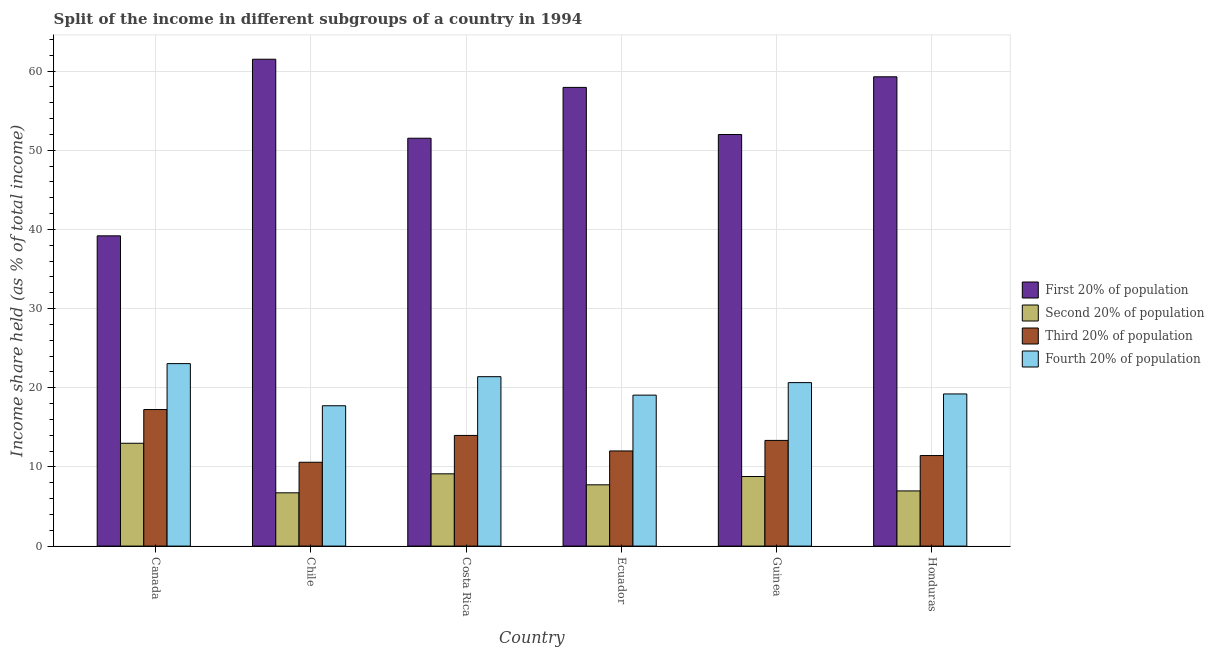Are the number of bars on each tick of the X-axis equal?
Provide a succinct answer. Yes. How many bars are there on the 6th tick from the right?
Keep it short and to the point. 4. What is the label of the 6th group of bars from the left?
Your answer should be compact. Honduras. What is the share of the income held by third 20% of the population in Honduras?
Give a very brief answer. 11.44. Across all countries, what is the maximum share of the income held by fourth 20% of the population?
Give a very brief answer. 23.05. Across all countries, what is the minimum share of the income held by first 20% of the population?
Give a very brief answer. 39.19. What is the total share of the income held by fourth 20% of the population in the graph?
Provide a succinct answer. 121.12. What is the difference between the share of the income held by third 20% of the population in Ecuador and that in Honduras?
Your response must be concise. 0.58. What is the difference between the share of the income held by fourth 20% of the population in Canada and the share of the income held by second 20% of the population in Chile?
Make the answer very short. 16.32. What is the average share of the income held by second 20% of the population per country?
Give a very brief answer. 8.72. What is the difference between the share of the income held by second 20% of the population and share of the income held by first 20% of the population in Canada?
Give a very brief answer. -26.2. What is the ratio of the share of the income held by third 20% of the population in Chile to that in Guinea?
Your response must be concise. 0.79. Is the share of the income held by fourth 20% of the population in Ecuador less than that in Honduras?
Offer a terse response. Yes. What is the difference between the highest and the second highest share of the income held by first 20% of the population?
Your answer should be compact. 2.22. What is the difference between the highest and the lowest share of the income held by third 20% of the population?
Give a very brief answer. 6.66. Is the sum of the share of the income held by third 20% of the population in Chile and Guinea greater than the maximum share of the income held by first 20% of the population across all countries?
Keep it short and to the point. No. What does the 3rd bar from the left in Costa Rica represents?
Make the answer very short. Third 20% of population. What does the 2nd bar from the right in Ecuador represents?
Your response must be concise. Third 20% of population. Is it the case that in every country, the sum of the share of the income held by first 20% of the population and share of the income held by second 20% of the population is greater than the share of the income held by third 20% of the population?
Give a very brief answer. Yes. Are all the bars in the graph horizontal?
Your answer should be very brief. No. How many countries are there in the graph?
Offer a very short reply. 6. Does the graph contain any zero values?
Give a very brief answer. No. Does the graph contain grids?
Your answer should be very brief. Yes. How many legend labels are there?
Ensure brevity in your answer.  4. How are the legend labels stacked?
Keep it short and to the point. Vertical. What is the title of the graph?
Provide a succinct answer. Split of the income in different subgroups of a country in 1994. What is the label or title of the X-axis?
Your response must be concise. Country. What is the label or title of the Y-axis?
Provide a succinct answer. Income share held (as % of total income). What is the Income share held (as % of total income) of First 20% of population in Canada?
Your response must be concise. 39.19. What is the Income share held (as % of total income) in Second 20% of population in Canada?
Your answer should be compact. 12.99. What is the Income share held (as % of total income) of Third 20% of population in Canada?
Your answer should be very brief. 17.25. What is the Income share held (as % of total income) in Fourth 20% of population in Canada?
Make the answer very short. 23.05. What is the Income share held (as % of total income) of First 20% of population in Chile?
Offer a terse response. 61.5. What is the Income share held (as % of total income) in Second 20% of population in Chile?
Provide a succinct answer. 6.73. What is the Income share held (as % of total income) in Third 20% of population in Chile?
Your response must be concise. 10.59. What is the Income share held (as % of total income) in Fourth 20% of population in Chile?
Your response must be concise. 17.73. What is the Income share held (as % of total income) in First 20% of population in Costa Rica?
Provide a short and direct response. 51.52. What is the Income share held (as % of total income) in Second 20% of population in Costa Rica?
Offer a very short reply. 9.13. What is the Income share held (as % of total income) of Third 20% of population in Costa Rica?
Provide a succinct answer. 13.98. What is the Income share held (as % of total income) of Fourth 20% of population in Costa Rica?
Offer a very short reply. 21.4. What is the Income share held (as % of total income) of First 20% of population in Ecuador?
Provide a short and direct response. 57.94. What is the Income share held (as % of total income) of Second 20% of population in Ecuador?
Your answer should be very brief. 7.74. What is the Income share held (as % of total income) of Third 20% of population in Ecuador?
Provide a succinct answer. 12.02. What is the Income share held (as % of total income) in Fourth 20% of population in Ecuador?
Give a very brief answer. 19.07. What is the Income share held (as % of total income) of First 20% of population in Guinea?
Your response must be concise. 51.99. What is the Income share held (as % of total income) in Second 20% of population in Guinea?
Make the answer very short. 8.79. What is the Income share held (as % of total income) in Third 20% of population in Guinea?
Ensure brevity in your answer.  13.35. What is the Income share held (as % of total income) of Fourth 20% of population in Guinea?
Your answer should be compact. 20.65. What is the Income share held (as % of total income) in First 20% of population in Honduras?
Keep it short and to the point. 59.28. What is the Income share held (as % of total income) of Second 20% of population in Honduras?
Give a very brief answer. 6.97. What is the Income share held (as % of total income) in Third 20% of population in Honduras?
Provide a short and direct response. 11.44. What is the Income share held (as % of total income) in Fourth 20% of population in Honduras?
Your response must be concise. 19.22. Across all countries, what is the maximum Income share held (as % of total income) of First 20% of population?
Your answer should be very brief. 61.5. Across all countries, what is the maximum Income share held (as % of total income) of Second 20% of population?
Offer a very short reply. 12.99. Across all countries, what is the maximum Income share held (as % of total income) of Third 20% of population?
Offer a very short reply. 17.25. Across all countries, what is the maximum Income share held (as % of total income) in Fourth 20% of population?
Your answer should be very brief. 23.05. Across all countries, what is the minimum Income share held (as % of total income) in First 20% of population?
Your answer should be compact. 39.19. Across all countries, what is the minimum Income share held (as % of total income) in Second 20% of population?
Ensure brevity in your answer.  6.73. Across all countries, what is the minimum Income share held (as % of total income) of Third 20% of population?
Provide a succinct answer. 10.59. Across all countries, what is the minimum Income share held (as % of total income) of Fourth 20% of population?
Provide a succinct answer. 17.73. What is the total Income share held (as % of total income) of First 20% of population in the graph?
Ensure brevity in your answer.  321.42. What is the total Income share held (as % of total income) of Second 20% of population in the graph?
Make the answer very short. 52.35. What is the total Income share held (as % of total income) of Third 20% of population in the graph?
Give a very brief answer. 78.63. What is the total Income share held (as % of total income) in Fourth 20% of population in the graph?
Offer a terse response. 121.12. What is the difference between the Income share held (as % of total income) of First 20% of population in Canada and that in Chile?
Provide a succinct answer. -22.31. What is the difference between the Income share held (as % of total income) in Second 20% of population in Canada and that in Chile?
Give a very brief answer. 6.26. What is the difference between the Income share held (as % of total income) of Third 20% of population in Canada and that in Chile?
Your response must be concise. 6.66. What is the difference between the Income share held (as % of total income) of Fourth 20% of population in Canada and that in Chile?
Make the answer very short. 5.32. What is the difference between the Income share held (as % of total income) in First 20% of population in Canada and that in Costa Rica?
Your answer should be very brief. -12.33. What is the difference between the Income share held (as % of total income) in Second 20% of population in Canada and that in Costa Rica?
Keep it short and to the point. 3.86. What is the difference between the Income share held (as % of total income) of Third 20% of population in Canada and that in Costa Rica?
Make the answer very short. 3.27. What is the difference between the Income share held (as % of total income) in Fourth 20% of population in Canada and that in Costa Rica?
Your answer should be compact. 1.65. What is the difference between the Income share held (as % of total income) in First 20% of population in Canada and that in Ecuador?
Your response must be concise. -18.75. What is the difference between the Income share held (as % of total income) in Second 20% of population in Canada and that in Ecuador?
Provide a succinct answer. 5.25. What is the difference between the Income share held (as % of total income) of Third 20% of population in Canada and that in Ecuador?
Offer a very short reply. 5.23. What is the difference between the Income share held (as % of total income) of Fourth 20% of population in Canada and that in Ecuador?
Provide a succinct answer. 3.98. What is the difference between the Income share held (as % of total income) of First 20% of population in Canada and that in Guinea?
Your answer should be very brief. -12.8. What is the difference between the Income share held (as % of total income) of Second 20% of population in Canada and that in Guinea?
Your response must be concise. 4.2. What is the difference between the Income share held (as % of total income) in Third 20% of population in Canada and that in Guinea?
Offer a terse response. 3.9. What is the difference between the Income share held (as % of total income) in Fourth 20% of population in Canada and that in Guinea?
Ensure brevity in your answer.  2.4. What is the difference between the Income share held (as % of total income) of First 20% of population in Canada and that in Honduras?
Your answer should be compact. -20.09. What is the difference between the Income share held (as % of total income) in Second 20% of population in Canada and that in Honduras?
Your response must be concise. 6.02. What is the difference between the Income share held (as % of total income) in Third 20% of population in Canada and that in Honduras?
Provide a succinct answer. 5.81. What is the difference between the Income share held (as % of total income) in Fourth 20% of population in Canada and that in Honduras?
Make the answer very short. 3.83. What is the difference between the Income share held (as % of total income) in First 20% of population in Chile and that in Costa Rica?
Provide a succinct answer. 9.98. What is the difference between the Income share held (as % of total income) in Second 20% of population in Chile and that in Costa Rica?
Offer a terse response. -2.4. What is the difference between the Income share held (as % of total income) in Third 20% of population in Chile and that in Costa Rica?
Keep it short and to the point. -3.39. What is the difference between the Income share held (as % of total income) of Fourth 20% of population in Chile and that in Costa Rica?
Ensure brevity in your answer.  -3.67. What is the difference between the Income share held (as % of total income) of First 20% of population in Chile and that in Ecuador?
Make the answer very short. 3.56. What is the difference between the Income share held (as % of total income) of Second 20% of population in Chile and that in Ecuador?
Offer a terse response. -1.01. What is the difference between the Income share held (as % of total income) of Third 20% of population in Chile and that in Ecuador?
Your response must be concise. -1.43. What is the difference between the Income share held (as % of total income) of Fourth 20% of population in Chile and that in Ecuador?
Give a very brief answer. -1.34. What is the difference between the Income share held (as % of total income) of First 20% of population in Chile and that in Guinea?
Your answer should be very brief. 9.51. What is the difference between the Income share held (as % of total income) of Second 20% of population in Chile and that in Guinea?
Offer a terse response. -2.06. What is the difference between the Income share held (as % of total income) in Third 20% of population in Chile and that in Guinea?
Offer a terse response. -2.76. What is the difference between the Income share held (as % of total income) in Fourth 20% of population in Chile and that in Guinea?
Your answer should be compact. -2.92. What is the difference between the Income share held (as % of total income) in First 20% of population in Chile and that in Honduras?
Ensure brevity in your answer.  2.22. What is the difference between the Income share held (as % of total income) in Second 20% of population in Chile and that in Honduras?
Make the answer very short. -0.24. What is the difference between the Income share held (as % of total income) of Third 20% of population in Chile and that in Honduras?
Provide a succinct answer. -0.85. What is the difference between the Income share held (as % of total income) in Fourth 20% of population in Chile and that in Honduras?
Make the answer very short. -1.49. What is the difference between the Income share held (as % of total income) of First 20% of population in Costa Rica and that in Ecuador?
Your answer should be compact. -6.42. What is the difference between the Income share held (as % of total income) of Second 20% of population in Costa Rica and that in Ecuador?
Keep it short and to the point. 1.39. What is the difference between the Income share held (as % of total income) in Third 20% of population in Costa Rica and that in Ecuador?
Your answer should be compact. 1.96. What is the difference between the Income share held (as % of total income) of Fourth 20% of population in Costa Rica and that in Ecuador?
Offer a terse response. 2.33. What is the difference between the Income share held (as % of total income) of First 20% of population in Costa Rica and that in Guinea?
Give a very brief answer. -0.47. What is the difference between the Income share held (as % of total income) in Second 20% of population in Costa Rica and that in Guinea?
Give a very brief answer. 0.34. What is the difference between the Income share held (as % of total income) of Third 20% of population in Costa Rica and that in Guinea?
Keep it short and to the point. 0.63. What is the difference between the Income share held (as % of total income) of First 20% of population in Costa Rica and that in Honduras?
Provide a succinct answer. -7.76. What is the difference between the Income share held (as % of total income) of Second 20% of population in Costa Rica and that in Honduras?
Your answer should be very brief. 2.16. What is the difference between the Income share held (as % of total income) of Third 20% of population in Costa Rica and that in Honduras?
Offer a terse response. 2.54. What is the difference between the Income share held (as % of total income) of Fourth 20% of population in Costa Rica and that in Honduras?
Your answer should be compact. 2.18. What is the difference between the Income share held (as % of total income) in First 20% of population in Ecuador and that in Guinea?
Ensure brevity in your answer.  5.95. What is the difference between the Income share held (as % of total income) in Second 20% of population in Ecuador and that in Guinea?
Your response must be concise. -1.05. What is the difference between the Income share held (as % of total income) of Third 20% of population in Ecuador and that in Guinea?
Offer a terse response. -1.33. What is the difference between the Income share held (as % of total income) of Fourth 20% of population in Ecuador and that in Guinea?
Ensure brevity in your answer.  -1.58. What is the difference between the Income share held (as % of total income) in First 20% of population in Ecuador and that in Honduras?
Offer a terse response. -1.34. What is the difference between the Income share held (as % of total income) of Second 20% of population in Ecuador and that in Honduras?
Offer a terse response. 0.77. What is the difference between the Income share held (as % of total income) of Third 20% of population in Ecuador and that in Honduras?
Give a very brief answer. 0.58. What is the difference between the Income share held (as % of total income) in First 20% of population in Guinea and that in Honduras?
Your answer should be compact. -7.29. What is the difference between the Income share held (as % of total income) of Second 20% of population in Guinea and that in Honduras?
Give a very brief answer. 1.82. What is the difference between the Income share held (as % of total income) in Third 20% of population in Guinea and that in Honduras?
Provide a short and direct response. 1.91. What is the difference between the Income share held (as % of total income) in Fourth 20% of population in Guinea and that in Honduras?
Your answer should be very brief. 1.43. What is the difference between the Income share held (as % of total income) in First 20% of population in Canada and the Income share held (as % of total income) in Second 20% of population in Chile?
Your response must be concise. 32.46. What is the difference between the Income share held (as % of total income) of First 20% of population in Canada and the Income share held (as % of total income) of Third 20% of population in Chile?
Make the answer very short. 28.6. What is the difference between the Income share held (as % of total income) of First 20% of population in Canada and the Income share held (as % of total income) of Fourth 20% of population in Chile?
Keep it short and to the point. 21.46. What is the difference between the Income share held (as % of total income) in Second 20% of population in Canada and the Income share held (as % of total income) in Fourth 20% of population in Chile?
Make the answer very short. -4.74. What is the difference between the Income share held (as % of total income) of Third 20% of population in Canada and the Income share held (as % of total income) of Fourth 20% of population in Chile?
Your answer should be very brief. -0.48. What is the difference between the Income share held (as % of total income) of First 20% of population in Canada and the Income share held (as % of total income) of Second 20% of population in Costa Rica?
Provide a succinct answer. 30.06. What is the difference between the Income share held (as % of total income) of First 20% of population in Canada and the Income share held (as % of total income) of Third 20% of population in Costa Rica?
Your answer should be compact. 25.21. What is the difference between the Income share held (as % of total income) of First 20% of population in Canada and the Income share held (as % of total income) of Fourth 20% of population in Costa Rica?
Your answer should be compact. 17.79. What is the difference between the Income share held (as % of total income) of Second 20% of population in Canada and the Income share held (as % of total income) of Third 20% of population in Costa Rica?
Your answer should be very brief. -0.99. What is the difference between the Income share held (as % of total income) in Second 20% of population in Canada and the Income share held (as % of total income) in Fourth 20% of population in Costa Rica?
Provide a short and direct response. -8.41. What is the difference between the Income share held (as % of total income) of Third 20% of population in Canada and the Income share held (as % of total income) of Fourth 20% of population in Costa Rica?
Provide a succinct answer. -4.15. What is the difference between the Income share held (as % of total income) of First 20% of population in Canada and the Income share held (as % of total income) of Second 20% of population in Ecuador?
Your answer should be very brief. 31.45. What is the difference between the Income share held (as % of total income) of First 20% of population in Canada and the Income share held (as % of total income) of Third 20% of population in Ecuador?
Your answer should be compact. 27.17. What is the difference between the Income share held (as % of total income) in First 20% of population in Canada and the Income share held (as % of total income) in Fourth 20% of population in Ecuador?
Your answer should be very brief. 20.12. What is the difference between the Income share held (as % of total income) of Second 20% of population in Canada and the Income share held (as % of total income) of Fourth 20% of population in Ecuador?
Your answer should be compact. -6.08. What is the difference between the Income share held (as % of total income) of Third 20% of population in Canada and the Income share held (as % of total income) of Fourth 20% of population in Ecuador?
Offer a terse response. -1.82. What is the difference between the Income share held (as % of total income) in First 20% of population in Canada and the Income share held (as % of total income) in Second 20% of population in Guinea?
Offer a very short reply. 30.4. What is the difference between the Income share held (as % of total income) of First 20% of population in Canada and the Income share held (as % of total income) of Third 20% of population in Guinea?
Provide a short and direct response. 25.84. What is the difference between the Income share held (as % of total income) of First 20% of population in Canada and the Income share held (as % of total income) of Fourth 20% of population in Guinea?
Keep it short and to the point. 18.54. What is the difference between the Income share held (as % of total income) in Second 20% of population in Canada and the Income share held (as % of total income) in Third 20% of population in Guinea?
Provide a short and direct response. -0.36. What is the difference between the Income share held (as % of total income) in Second 20% of population in Canada and the Income share held (as % of total income) in Fourth 20% of population in Guinea?
Ensure brevity in your answer.  -7.66. What is the difference between the Income share held (as % of total income) of Third 20% of population in Canada and the Income share held (as % of total income) of Fourth 20% of population in Guinea?
Your answer should be compact. -3.4. What is the difference between the Income share held (as % of total income) in First 20% of population in Canada and the Income share held (as % of total income) in Second 20% of population in Honduras?
Give a very brief answer. 32.22. What is the difference between the Income share held (as % of total income) of First 20% of population in Canada and the Income share held (as % of total income) of Third 20% of population in Honduras?
Make the answer very short. 27.75. What is the difference between the Income share held (as % of total income) in First 20% of population in Canada and the Income share held (as % of total income) in Fourth 20% of population in Honduras?
Offer a very short reply. 19.97. What is the difference between the Income share held (as % of total income) in Second 20% of population in Canada and the Income share held (as % of total income) in Third 20% of population in Honduras?
Make the answer very short. 1.55. What is the difference between the Income share held (as % of total income) in Second 20% of population in Canada and the Income share held (as % of total income) in Fourth 20% of population in Honduras?
Your answer should be compact. -6.23. What is the difference between the Income share held (as % of total income) in Third 20% of population in Canada and the Income share held (as % of total income) in Fourth 20% of population in Honduras?
Provide a succinct answer. -1.97. What is the difference between the Income share held (as % of total income) of First 20% of population in Chile and the Income share held (as % of total income) of Second 20% of population in Costa Rica?
Ensure brevity in your answer.  52.37. What is the difference between the Income share held (as % of total income) in First 20% of population in Chile and the Income share held (as % of total income) in Third 20% of population in Costa Rica?
Offer a very short reply. 47.52. What is the difference between the Income share held (as % of total income) in First 20% of population in Chile and the Income share held (as % of total income) in Fourth 20% of population in Costa Rica?
Ensure brevity in your answer.  40.1. What is the difference between the Income share held (as % of total income) in Second 20% of population in Chile and the Income share held (as % of total income) in Third 20% of population in Costa Rica?
Make the answer very short. -7.25. What is the difference between the Income share held (as % of total income) in Second 20% of population in Chile and the Income share held (as % of total income) in Fourth 20% of population in Costa Rica?
Provide a short and direct response. -14.67. What is the difference between the Income share held (as % of total income) in Third 20% of population in Chile and the Income share held (as % of total income) in Fourth 20% of population in Costa Rica?
Your answer should be compact. -10.81. What is the difference between the Income share held (as % of total income) of First 20% of population in Chile and the Income share held (as % of total income) of Second 20% of population in Ecuador?
Provide a succinct answer. 53.76. What is the difference between the Income share held (as % of total income) of First 20% of population in Chile and the Income share held (as % of total income) of Third 20% of population in Ecuador?
Your answer should be very brief. 49.48. What is the difference between the Income share held (as % of total income) in First 20% of population in Chile and the Income share held (as % of total income) in Fourth 20% of population in Ecuador?
Make the answer very short. 42.43. What is the difference between the Income share held (as % of total income) in Second 20% of population in Chile and the Income share held (as % of total income) in Third 20% of population in Ecuador?
Your answer should be compact. -5.29. What is the difference between the Income share held (as % of total income) of Second 20% of population in Chile and the Income share held (as % of total income) of Fourth 20% of population in Ecuador?
Offer a terse response. -12.34. What is the difference between the Income share held (as % of total income) in Third 20% of population in Chile and the Income share held (as % of total income) in Fourth 20% of population in Ecuador?
Offer a terse response. -8.48. What is the difference between the Income share held (as % of total income) of First 20% of population in Chile and the Income share held (as % of total income) of Second 20% of population in Guinea?
Your answer should be compact. 52.71. What is the difference between the Income share held (as % of total income) in First 20% of population in Chile and the Income share held (as % of total income) in Third 20% of population in Guinea?
Offer a very short reply. 48.15. What is the difference between the Income share held (as % of total income) of First 20% of population in Chile and the Income share held (as % of total income) of Fourth 20% of population in Guinea?
Provide a short and direct response. 40.85. What is the difference between the Income share held (as % of total income) of Second 20% of population in Chile and the Income share held (as % of total income) of Third 20% of population in Guinea?
Your answer should be very brief. -6.62. What is the difference between the Income share held (as % of total income) of Second 20% of population in Chile and the Income share held (as % of total income) of Fourth 20% of population in Guinea?
Offer a very short reply. -13.92. What is the difference between the Income share held (as % of total income) of Third 20% of population in Chile and the Income share held (as % of total income) of Fourth 20% of population in Guinea?
Give a very brief answer. -10.06. What is the difference between the Income share held (as % of total income) in First 20% of population in Chile and the Income share held (as % of total income) in Second 20% of population in Honduras?
Give a very brief answer. 54.53. What is the difference between the Income share held (as % of total income) of First 20% of population in Chile and the Income share held (as % of total income) of Third 20% of population in Honduras?
Give a very brief answer. 50.06. What is the difference between the Income share held (as % of total income) in First 20% of population in Chile and the Income share held (as % of total income) in Fourth 20% of population in Honduras?
Offer a very short reply. 42.28. What is the difference between the Income share held (as % of total income) in Second 20% of population in Chile and the Income share held (as % of total income) in Third 20% of population in Honduras?
Keep it short and to the point. -4.71. What is the difference between the Income share held (as % of total income) in Second 20% of population in Chile and the Income share held (as % of total income) in Fourth 20% of population in Honduras?
Your answer should be very brief. -12.49. What is the difference between the Income share held (as % of total income) of Third 20% of population in Chile and the Income share held (as % of total income) of Fourth 20% of population in Honduras?
Give a very brief answer. -8.63. What is the difference between the Income share held (as % of total income) of First 20% of population in Costa Rica and the Income share held (as % of total income) of Second 20% of population in Ecuador?
Offer a very short reply. 43.78. What is the difference between the Income share held (as % of total income) in First 20% of population in Costa Rica and the Income share held (as % of total income) in Third 20% of population in Ecuador?
Your response must be concise. 39.5. What is the difference between the Income share held (as % of total income) in First 20% of population in Costa Rica and the Income share held (as % of total income) in Fourth 20% of population in Ecuador?
Your answer should be very brief. 32.45. What is the difference between the Income share held (as % of total income) in Second 20% of population in Costa Rica and the Income share held (as % of total income) in Third 20% of population in Ecuador?
Your answer should be compact. -2.89. What is the difference between the Income share held (as % of total income) in Second 20% of population in Costa Rica and the Income share held (as % of total income) in Fourth 20% of population in Ecuador?
Your answer should be compact. -9.94. What is the difference between the Income share held (as % of total income) in Third 20% of population in Costa Rica and the Income share held (as % of total income) in Fourth 20% of population in Ecuador?
Your answer should be very brief. -5.09. What is the difference between the Income share held (as % of total income) of First 20% of population in Costa Rica and the Income share held (as % of total income) of Second 20% of population in Guinea?
Provide a succinct answer. 42.73. What is the difference between the Income share held (as % of total income) of First 20% of population in Costa Rica and the Income share held (as % of total income) of Third 20% of population in Guinea?
Your answer should be very brief. 38.17. What is the difference between the Income share held (as % of total income) of First 20% of population in Costa Rica and the Income share held (as % of total income) of Fourth 20% of population in Guinea?
Offer a very short reply. 30.87. What is the difference between the Income share held (as % of total income) of Second 20% of population in Costa Rica and the Income share held (as % of total income) of Third 20% of population in Guinea?
Provide a short and direct response. -4.22. What is the difference between the Income share held (as % of total income) of Second 20% of population in Costa Rica and the Income share held (as % of total income) of Fourth 20% of population in Guinea?
Your response must be concise. -11.52. What is the difference between the Income share held (as % of total income) of Third 20% of population in Costa Rica and the Income share held (as % of total income) of Fourth 20% of population in Guinea?
Your answer should be very brief. -6.67. What is the difference between the Income share held (as % of total income) of First 20% of population in Costa Rica and the Income share held (as % of total income) of Second 20% of population in Honduras?
Provide a short and direct response. 44.55. What is the difference between the Income share held (as % of total income) in First 20% of population in Costa Rica and the Income share held (as % of total income) in Third 20% of population in Honduras?
Your answer should be compact. 40.08. What is the difference between the Income share held (as % of total income) of First 20% of population in Costa Rica and the Income share held (as % of total income) of Fourth 20% of population in Honduras?
Offer a very short reply. 32.3. What is the difference between the Income share held (as % of total income) of Second 20% of population in Costa Rica and the Income share held (as % of total income) of Third 20% of population in Honduras?
Keep it short and to the point. -2.31. What is the difference between the Income share held (as % of total income) in Second 20% of population in Costa Rica and the Income share held (as % of total income) in Fourth 20% of population in Honduras?
Give a very brief answer. -10.09. What is the difference between the Income share held (as % of total income) of Third 20% of population in Costa Rica and the Income share held (as % of total income) of Fourth 20% of population in Honduras?
Provide a short and direct response. -5.24. What is the difference between the Income share held (as % of total income) in First 20% of population in Ecuador and the Income share held (as % of total income) in Second 20% of population in Guinea?
Ensure brevity in your answer.  49.15. What is the difference between the Income share held (as % of total income) in First 20% of population in Ecuador and the Income share held (as % of total income) in Third 20% of population in Guinea?
Ensure brevity in your answer.  44.59. What is the difference between the Income share held (as % of total income) of First 20% of population in Ecuador and the Income share held (as % of total income) of Fourth 20% of population in Guinea?
Provide a succinct answer. 37.29. What is the difference between the Income share held (as % of total income) in Second 20% of population in Ecuador and the Income share held (as % of total income) in Third 20% of population in Guinea?
Give a very brief answer. -5.61. What is the difference between the Income share held (as % of total income) in Second 20% of population in Ecuador and the Income share held (as % of total income) in Fourth 20% of population in Guinea?
Give a very brief answer. -12.91. What is the difference between the Income share held (as % of total income) of Third 20% of population in Ecuador and the Income share held (as % of total income) of Fourth 20% of population in Guinea?
Ensure brevity in your answer.  -8.63. What is the difference between the Income share held (as % of total income) of First 20% of population in Ecuador and the Income share held (as % of total income) of Second 20% of population in Honduras?
Provide a succinct answer. 50.97. What is the difference between the Income share held (as % of total income) in First 20% of population in Ecuador and the Income share held (as % of total income) in Third 20% of population in Honduras?
Offer a very short reply. 46.5. What is the difference between the Income share held (as % of total income) in First 20% of population in Ecuador and the Income share held (as % of total income) in Fourth 20% of population in Honduras?
Give a very brief answer. 38.72. What is the difference between the Income share held (as % of total income) in Second 20% of population in Ecuador and the Income share held (as % of total income) in Fourth 20% of population in Honduras?
Give a very brief answer. -11.48. What is the difference between the Income share held (as % of total income) in First 20% of population in Guinea and the Income share held (as % of total income) in Second 20% of population in Honduras?
Keep it short and to the point. 45.02. What is the difference between the Income share held (as % of total income) in First 20% of population in Guinea and the Income share held (as % of total income) in Third 20% of population in Honduras?
Offer a terse response. 40.55. What is the difference between the Income share held (as % of total income) of First 20% of population in Guinea and the Income share held (as % of total income) of Fourth 20% of population in Honduras?
Your answer should be compact. 32.77. What is the difference between the Income share held (as % of total income) in Second 20% of population in Guinea and the Income share held (as % of total income) in Third 20% of population in Honduras?
Provide a succinct answer. -2.65. What is the difference between the Income share held (as % of total income) of Second 20% of population in Guinea and the Income share held (as % of total income) of Fourth 20% of population in Honduras?
Provide a succinct answer. -10.43. What is the difference between the Income share held (as % of total income) of Third 20% of population in Guinea and the Income share held (as % of total income) of Fourth 20% of population in Honduras?
Offer a very short reply. -5.87. What is the average Income share held (as % of total income) in First 20% of population per country?
Provide a succinct answer. 53.57. What is the average Income share held (as % of total income) of Second 20% of population per country?
Keep it short and to the point. 8.72. What is the average Income share held (as % of total income) in Third 20% of population per country?
Your answer should be very brief. 13.11. What is the average Income share held (as % of total income) in Fourth 20% of population per country?
Keep it short and to the point. 20.19. What is the difference between the Income share held (as % of total income) of First 20% of population and Income share held (as % of total income) of Second 20% of population in Canada?
Your answer should be very brief. 26.2. What is the difference between the Income share held (as % of total income) in First 20% of population and Income share held (as % of total income) in Third 20% of population in Canada?
Give a very brief answer. 21.94. What is the difference between the Income share held (as % of total income) of First 20% of population and Income share held (as % of total income) of Fourth 20% of population in Canada?
Make the answer very short. 16.14. What is the difference between the Income share held (as % of total income) of Second 20% of population and Income share held (as % of total income) of Third 20% of population in Canada?
Your answer should be very brief. -4.26. What is the difference between the Income share held (as % of total income) in Second 20% of population and Income share held (as % of total income) in Fourth 20% of population in Canada?
Provide a short and direct response. -10.06. What is the difference between the Income share held (as % of total income) of Third 20% of population and Income share held (as % of total income) of Fourth 20% of population in Canada?
Your answer should be very brief. -5.8. What is the difference between the Income share held (as % of total income) of First 20% of population and Income share held (as % of total income) of Second 20% of population in Chile?
Give a very brief answer. 54.77. What is the difference between the Income share held (as % of total income) in First 20% of population and Income share held (as % of total income) in Third 20% of population in Chile?
Your answer should be very brief. 50.91. What is the difference between the Income share held (as % of total income) in First 20% of population and Income share held (as % of total income) in Fourth 20% of population in Chile?
Provide a succinct answer. 43.77. What is the difference between the Income share held (as % of total income) in Second 20% of population and Income share held (as % of total income) in Third 20% of population in Chile?
Your response must be concise. -3.86. What is the difference between the Income share held (as % of total income) in Second 20% of population and Income share held (as % of total income) in Fourth 20% of population in Chile?
Provide a short and direct response. -11. What is the difference between the Income share held (as % of total income) of Third 20% of population and Income share held (as % of total income) of Fourth 20% of population in Chile?
Provide a succinct answer. -7.14. What is the difference between the Income share held (as % of total income) in First 20% of population and Income share held (as % of total income) in Second 20% of population in Costa Rica?
Provide a succinct answer. 42.39. What is the difference between the Income share held (as % of total income) of First 20% of population and Income share held (as % of total income) of Third 20% of population in Costa Rica?
Your response must be concise. 37.54. What is the difference between the Income share held (as % of total income) of First 20% of population and Income share held (as % of total income) of Fourth 20% of population in Costa Rica?
Offer a very short reply. 30.12. What is the difference between the Income share held (as % of total income) in Second 20% of population and Income share held (as % of total income) in Third 20% of population in Costa Rica?
Your answer should be compact. -4.85. What is the difference between the Income share held (as % of total income) of Second 20% of population and Income share held (as % of total income) of Fourth 20% of population in Costa Rica?
Keep it short and to the point. -12.27. What is the difference between the Income share held (as % of total income) of Third 20% of population and Income share held (as % of total income) of Fourth 20% of population in Costa Rica?
Make the answer very short. -7.42. What is the difference between the Income share held (as % of total income) in First 20% of population and Income share held (as % of total income) in Second 20% of population in Ecuador?
Your response must be concise. 50.2. What is the difference between the Income share held (as % of total income) of First 20% of population and Income share held (as % of total income) of Third 20% of population in Ecuador?
Your answer should be compact. 45.92. What is the difference between the Income share held (as % of total income) of First 20% of population and Income share held (as % of total income) of Fourth 20% of population in Ecuador?
Keep it short and to the point. 38.87. What is the difference between the Income share held (as % of total income) in Second 20% of population and Income share held (as % of total income) in Third 20% of population in Ecuador?
Provide a succinct answer. -4.28. What is the difference between the Income share held (as % of total income) of Second 20% of population and Income share held (as % of total income) of Fourth 20% of population in Ecuador?
Make the answer very short. -11.33. What is the difference between the Income share held (as % of total income) of Third 20% of population and Income share held (as % of total income) of Fourth 20% of population in Ecuador?
Your response must be concise. -7.05. What is the difference between the Income share held (as % of total income) of First 20% of population and Income share held (as % of total income) of Second 20% of population in Guinea?
Your response must be concise. 43.2. What is the difference between the Income share held (as % of total income) of First 20% of population and Income share held (as % of total income) of Third 20% of population in Guinea?
Provide a short and direct response. 38.64. What is the difference between the Income share held (as % of total income) in First 20% of population and Income share held (as % of total income) in Fourth 20% of population in Guinea?
Offer a very short reply. 31.34. What is the difference between the Income share held (as % of total income) in Second 20% of population and Income share held (as % of total income) in Third 20% of population in Guinea?
Your answer should be compact. -4.56. What is the difference between the Income share held (as % of total income) of Second 20% of population and Income share held (as % of total income) of Fourth 20% of population in Guinea?
Your answer should be compact. -11.86. What is the difference between the Income share held (as % of total income) in Third 20% of population and Income share held (as % of total income) in Fourth 20% of population in Guinea?
Your response must be concise. -7.3. What is the difference between the Income share held (as % of total income) in First 20% of population and Income share held (as % of total income) in Second 20% of population in Honduras?
Give a very brief answer. 52.31. What is the difference between the Income share held (as % of total income) in First 20% of population and Income share held (as % of total income) in Third 20% of population in Honduras?
Make the answer very short. 47.84. What is the difference between the Income share held (as % of total income) of First 20% of population and Income share held (as % of total income) of Fourth 20% of population in Honduras?
Your answer should be compact. 40.06. What is the difference between the Income share held (as % of total income) of Second 20% of population and Income share held (as % of total income) of Third 20% of population in Honduras?
Offer a very short reply. -4.47. What is the difference between the Income share held (as % of total income) of Second 20% of population and Income share held (as % of total income) of Fourth 20% of population in Honduras?
Ensure brevity in your answer.  -12.25. What is the difference between the Income share held (as % of total income) in Third 20% of population and Income share held (as % of total income) in Fourth 20% of population in Honduras?
Provide a short and direct response. -7.78. What is the ratio of the Income share held (as % of total income) in First 20% of population in Canada to that in Chile?
Provide a short and direct response. 0.64. What is the ratio of the Income share held (as % of total income) of Second 20% of population in Canada to that in Chile?
Your answer should be compact. 1.93. What is the ratio of the Income share held (as % of total income) in Third 20% of population in Canada to that in Chile?
Provide a succinct answer. 1.63. What is the ratio of the Income share held (as % of total income) in Fourth 20% of population in Canada to that in Chile?
Keep it short and to the point. 1.3. What is the ratio of the Income share held (as % of total income) in First 20% of population in Canada to that in Costa Rica?
Your answer should be compact. 0.76. What is the ratio of the Income share held (as % of total income) of Second 20% of population in Canada to that in Costa Rica?
Ensure brevity in your answer.  1.42. What is the ratio of the Income share held (as % of total income) of Third 20% of population in Canada to that in Costa Rica?
Your response must be concise. 1.23. What is the ratio of the Income share held (as % of total income) in Fourth 20% of population in Canada to that in Costa Rica?
Give a very brief answer. 1.08. What is the ratio of the Income share held (as % of total income) of First 20% of population in Canada to that in Ecuador?
Make the answer very short. 0.68. What is the ratio of the Income share held (as % of total income) of Second 20% of population in Canada to that in Ecuador?
Provide a succinct answer. 1.68. What is the ratio of the Income share held (as % of total income) in Third 20% of population in Canada to that in Ecuador?
Keep it short and to the point. 1.44. What is the ratio of the Income share held (as % of total income) of Fourth 20% of population in Canada to that in Ecuador?
Give a very brief answer. 1.21. What is the ratio of the Income share held (as % of total income) of First 20% of population in Canada to that in Guinea?
Make the answer very short. 0.75. What is the ratio of the Income share held (as % of total income) of Second 20% of population in Canada to that in Guinea?
Provide a short and direct response. 1.48. What is the ratio of the Income share held (as % of total income) in Third 20% of population in Canada to that in Guinea?
Your response must be concise. 1.29. What is the ratio of the Income share held (as % of total income) in Fourth 20% of population in Canada to that in Guinea?
Give a very brief answer. 1.12. What is the ratio of the Income share held (as % of total income) of First 20% of population in Canada to that in Honduras?
Provide a short and direct response. 0.66. What is the ratio of the Income share held (as % of total income) in Second 20% of population in Canada to that in Honduras?
Keep it short and to the point. 1.86. What is the ratio of the Income share held (as % of total income) of Third 20% of population in Canada to that in Honduras?
Offer a very short reply. 1.51. What is the ratio of the Income share held (as % of total income) of Fourth 20% of population in Canada to that in Honduras?
Offer a very short reply. 1.2. What is the ratio of the Income share held (as % of total income) of First 20% of population in Chile to that in Costa Rica?
Give a very brief answer. 1.19. What is the ratio of the Income share held (as % of total income) in Second 20% of population in Chile to that in Costa Rica?
Your answer should be very brief. 0.74. What is the ratio of the Income share held (as % of total income) in Third 20% of population in Chile to that in Costa Rica?
Offer a very short reply. 0.76. What is the ratio of the Income share held (as % of total income) of Fourth 20% of population in Chile to that in Costa Rica?
Make the answer very short. 0.83. What is the ratio of the Income share held (as % of total income) in First 20% of population in Chile to that in Ecuador?
Provide a succinct answer. 1.06. What is the ratio of the Income share held (as % of total income) in Second 20% of population in Chile to that in Ecuador?
Offer a very short reply. 0.87. What is the ratio of the Income share held (as % of total income) of Third 20% of population in Chile to that in Ecuador?
Your answer should be compact. 0.88. What is the ratio of the Income share held (as % of total income) of Fourth 20% of population in Chile to that in Ecuador?
Offer a terse response. 0.93. What is the ratio of the Income share held (as % of total income) in First 20% of population in Chile to that in Guinea?
Keep it short and to the point. 1.18. What is the ratio of the Income share held (as % of total income) in Second 20% of population in Chile to that in Guinea?
Your response must be concise. 0.77. What is the ratio of the Income share held (as % of total income) of Third 20% of population in Chile to that in Guinea?
Your answer should be compact. 0.79. What is the ratio of the Income share held (as % of total income) of Fourth 20% of population in Chile to that in Guinea?
Offer a very short reply. 0.86. What is the ratio of the Income share held (as % of total income) in First 20% of population in Chile to that in Honduras?
Offer a terse response. 1.04. What is the ratio of the Income share held (as % of total income) of Second 20% of population in Chile to that in Honduras?
Provide a short and direct response. 0.97. What is the ratio of the Income share held (as % of total income) in Third 20% of population in Chile to that in Honduras?
Make the answer very short. 0.93. What is the ratio of the Income share held (as % of total income) of Fourth 20% of population in Chile to that in Honduras?
Your response must be concise. 0.92. What is the ratio of the Income share held (as % of total income) of First 20% of population in Costa Rica to that in Ecuador?
Ensure brevity in your answer.  0.89. What is the ratio of the Income share held (as % of total income) of Second 20% of population in Costa Rica to that in Ecuador?
Your response must be concise. 1.18. What is the ratio of the Income share held (as % of total income) in Third 20% of population in Costa Rica to that in Ecuador?
Your answer should be very brief. 1.16. What is the ratio of the Income share held (as % of total income) of Fourth 20% of population in Costa Rica to that in Ecuador?
Keep it short and to the point. 1.12. What is the ratio of the Income share held (as % of total income) in First 20% of population in Costa Rica to that in Guinea?
Give a very brief answer. 0.99. What is the ratio of the Income share held (as % of total income) in Second 20% of population in Costa Rica to that in Guinea?
Keep it short and to the point. 1.04. What is the ratio of the Income share held (as % of total income) in Third 20% of population in Costa Rica to that in Guinea?
Offer a very short reply. 1.05. What is the ratio of the Income share held (as % of total income) of Fourth 20% of population in Costa Rica to that in Guinea?
Provide a short and direct response. 1.04. What is the ratio of the Income share held (as % of total income) in First 20% of population in Costa Rica to that in Honduras?
Offer a terse response. 0.87. What is the ratio of the Income share held (as % of total income) in Second 20% of population in Costa Rica to that in Honduras?
Ensure brevity in your answer.  1.31. What is the ratio of the Income share held (as % of total income) in Third 20% of population in Costa Rica to that in Honduras?
Offer a terse response. 1.22. What is the ratio of the Income share held (as % of total income) of Fourth 20% of population in Costa Rica to that in Honduras?
Offer a very short reply. 1.11. What is the ratio of the Income share held (as % of total income) in First 20% of population in Ecuador to that in Guinea?
Your response must be concise. 1.11. What is the ratio of the Income share held (as % of total income) of Second 20% of population in Ecuador to that in Guinea?
Your response must be concise. 0.88. What is the ratio of the Income share held (as % of total income) in Third 20% of population in Ecuador to that in Guinea?
Your answer should be very brief. 0.9. What is the ratio of the Income share held (as % of total income) in Fourth 20% of population in Ecuador to that in Guinea?
Keep it short and to the point. 0.92. What is the ratio of the Income share held (as % of total income) of First 20% of population in Ecuador to that in Honduras?
Your answer should be compact. 0.98. What is the ratio of the Income share held (as % of total income) of Second 20% of population in Ecuador to that in Honduras?
Keep it short and to the point. 1.11. What is the ratio of the Income share held (as % of total income) in Third 20% of population in Ecuador to that in Honduras?
Make the answer very short. 1.05. What is the ratio of the Income share held (as % of total income) of Fourth 20% of population in Ecuador to that in Honduras?
Ensure brevity in your answer.  0.99. What is the ratio of the Income share held (as % of total income) of First 20% of population in Guinea to that in Honduras?
Make the answer very short. 0.88. What is the ratio of the Income share held (as % of total income) in Second 20% of population in Guinea to that in Honduras?
Your response must be concise. 1.26. What is the ratio of the Income share held (as % of total income) of Third 20% of population in Guinea to that in Honduras?
Offer a very short reply. 1.17. What is the ratio of the Income share held (as % of total income) in Fourth 20% of population in Guinea to that in Honduras?
Offer a very short reply. 1.07. What is the difference between the highest and the second highest Income share held (as % of total income) of First 20% of population?
Provide a succinct answer. 2.22. What is the difference between the highest and the second highest Income share held (as % of total income) in Second 20% of population?
Give a very brief answer. 3.86. What is the difference between the highest and the second highest Income share held (as % of total income) in Third 20% of population?
Give a very brief answer. 3.27. What is the difference between the highest and the second highest Income share held (as % of total income) of Fourth 20% of population?
Offer a terse response. 1.65. What is the difference between the highest and the lowest Income share held (as % of total income) in First 20% of population?
Keep it short and to the point. 22.31. What is the difference between the highest and the lowest Income share held (as % of total income) in Second 20% of population?
Your answer should be very brief. 6.26. What is the difference between the highest and the lowest Income share held (as % of total income) in Third 20% of population?
Your response must be concise. 6.66. What is the difference between the highest and the lowest Income share held (as % of total income) of Fourth 20% of population?
Your answer should be compact. 5.32. 